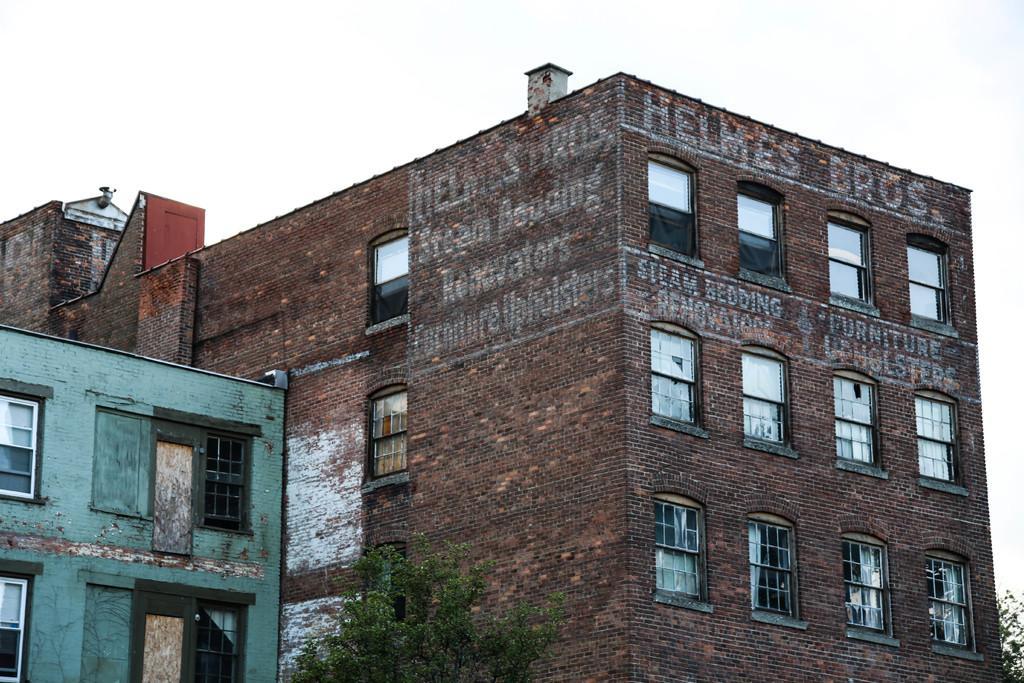In one or two sentences, can you explain what this image depicts? In this image in the center there are buildings and in the front there is a tree. On the wall of the building there is some text written and the sky is cloudy. 